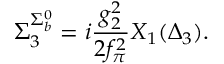Convert formula to latex. <formula><loc_0><loc_0><loc_500><loc_500>\Sigma _ { 3 } ^ { \Sigma _ { b } ^ { 0 } } = i \frac { g _ { 2 } ^ { 2 } } { 2 f _ { \pi } ^ { 2 } } X _ { 1 } ( \Delta _ { 3 } ) .</formula> 